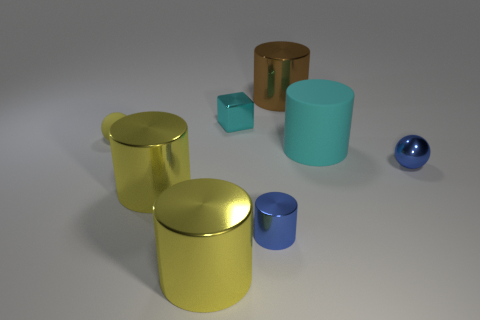What is the shape of the metallic object that is the same color as the tiny metal cylinder?
Provide a short and direct response. Sphere. Is the tiny ball behind the cyan rubber cylinder made of the same material as the small cylinder?
Ensure brevity in your answer.  No. There is a large thing that is both in front of the small yellow matte thing and right of the blue metallic cylinder; what is its material?
Make the answer very short. Rubber. What size is the cube that is the same color as the big rubber cylinder?
Offer a terse response. Small. The ball that is on the right side of the tiny metallic object that is in front of the metal sphere is made of what material?
Your answer should be very brief. Metal. There is a metallic object that is left of the large cylinder in front of the blue object that is in front of the tiny shiny sphere; how big is it?
Offer a terse response. Large. How many big cyan cylinders have the same material as the large brown cylinder?
Provide a succinct answer. 0. There is a ball that is left of the large rubber cylinder in front of the cyan metal block; what is its color?
Give a very brief answer. Yellow. What number of things are metallic objects or tiny metal things behind the big matte thing?
Provide a short and direct response. 6. Are there any tiny rubber spheres of the same color as the matte cylinder?
Your answer should be very brief. No. 